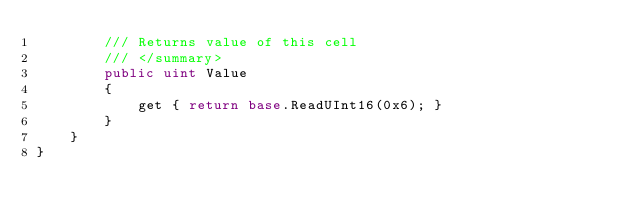Convert code to text. <code><loc_0><loc_0><loc_500><loc_500><_C#_>		/// Returns value of this cell
		/// </summary>
		public uint Value
		{
			get { return base.ReadUInt16(0x6); }
		}
	}
}</code> 